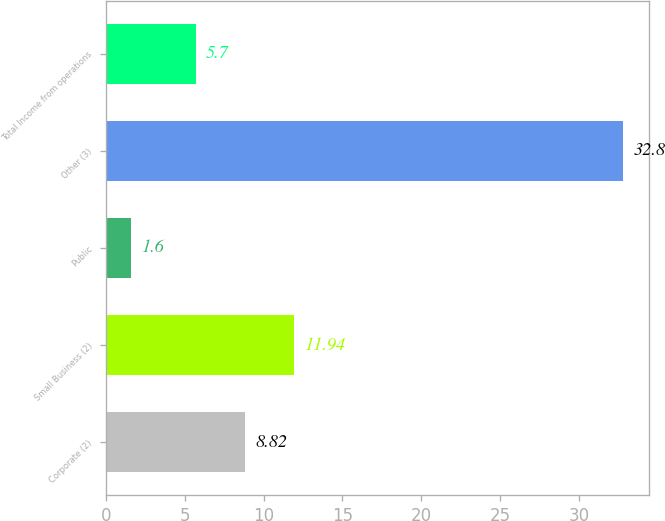Convert chart to OTSL. <chart><loc_0><loc_0><loc_500><loc_500><bar_chart><fcel>Corporate (2)<fcel>Small Business (2)<fcel>Public<fcel>Other (3)<fcel>Total Income from operations<nl><fcel>8.82<fcel>11.94<fcel>1.6<fcel>32.8<fcel>5.7<nl></chart> 